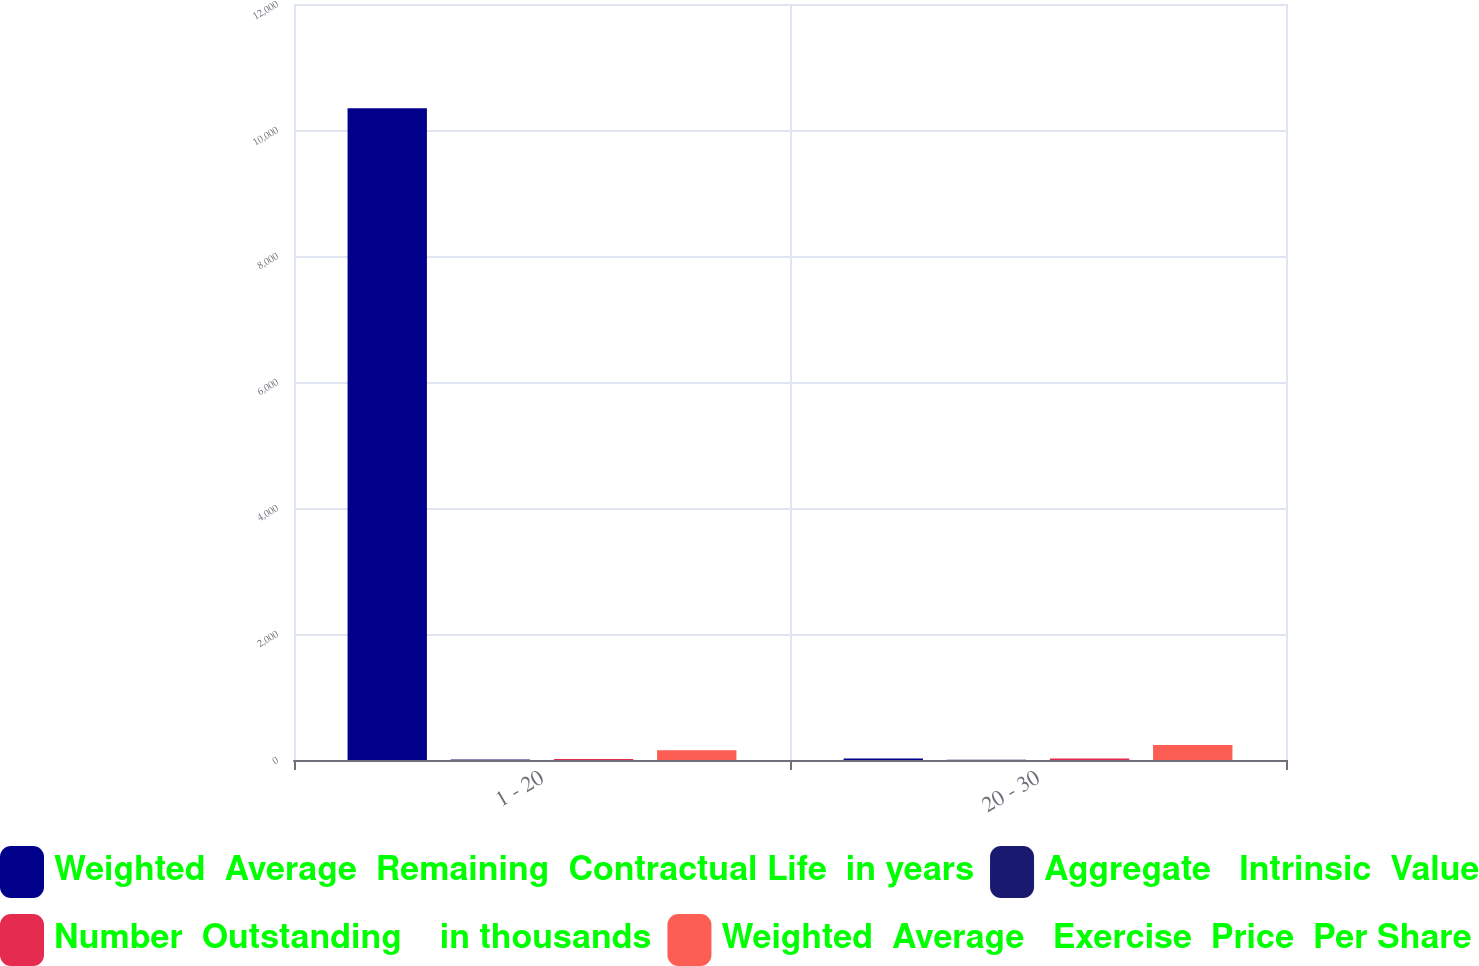Convert chart. <chart><loc_0><loc_0><loc_500><loc_500><stacked_bar_chart><ecel><fcel>1 - 20<fcel>20 - 30<nl><fcel>Weighted  Average  Remaining  Contractual Life  in years<fcel>10344<fcel>25.06<nl><fcel>Aggregate   Intrinsic  Value<fcel>6.16<fcel>3<nl><fcel>Number  Outstanding    in thousands<fcel>17.51<fcel>25.06<nl><fcel>Weighted  Average   Exercise  Price  Per Share<fcel>156<fcel>238<nl></chart> 